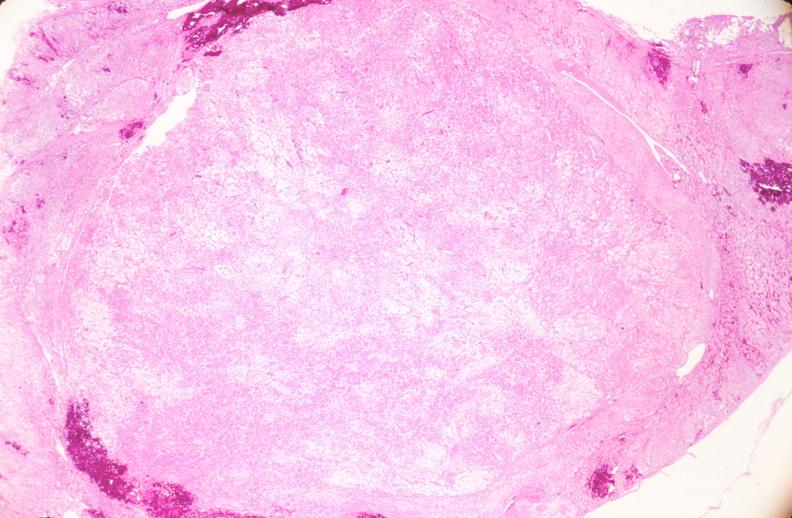s intraductal papillomatosis present?
Answer the question using a single word or phrase. No 